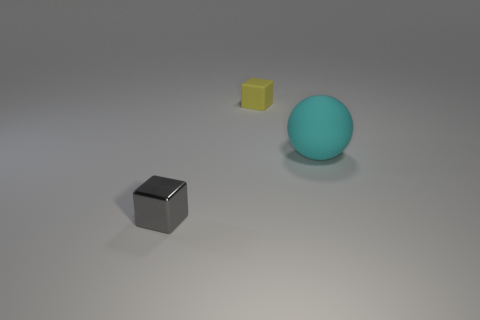Add 3 cyan rubber objects. How many objects exist? 6 Subtract all gray blocks. How many blocks are left? 1 Subtract all balls. How many objects are left? 2 Subtract all yellow balls. Subtract all gray cylinders. How many balls are left? 1 Subtract all tiny gray blocks. Subtract all tiny gray cubes. How many objects are left? 1 Add 1 tiny gray metal blocks. How many tiny gray metal blocks are left? 2 Add 3 tiny cubes. How many tiny cubes exist? 5 Subtract 0 purple cylinders. How many objects are left? 3 